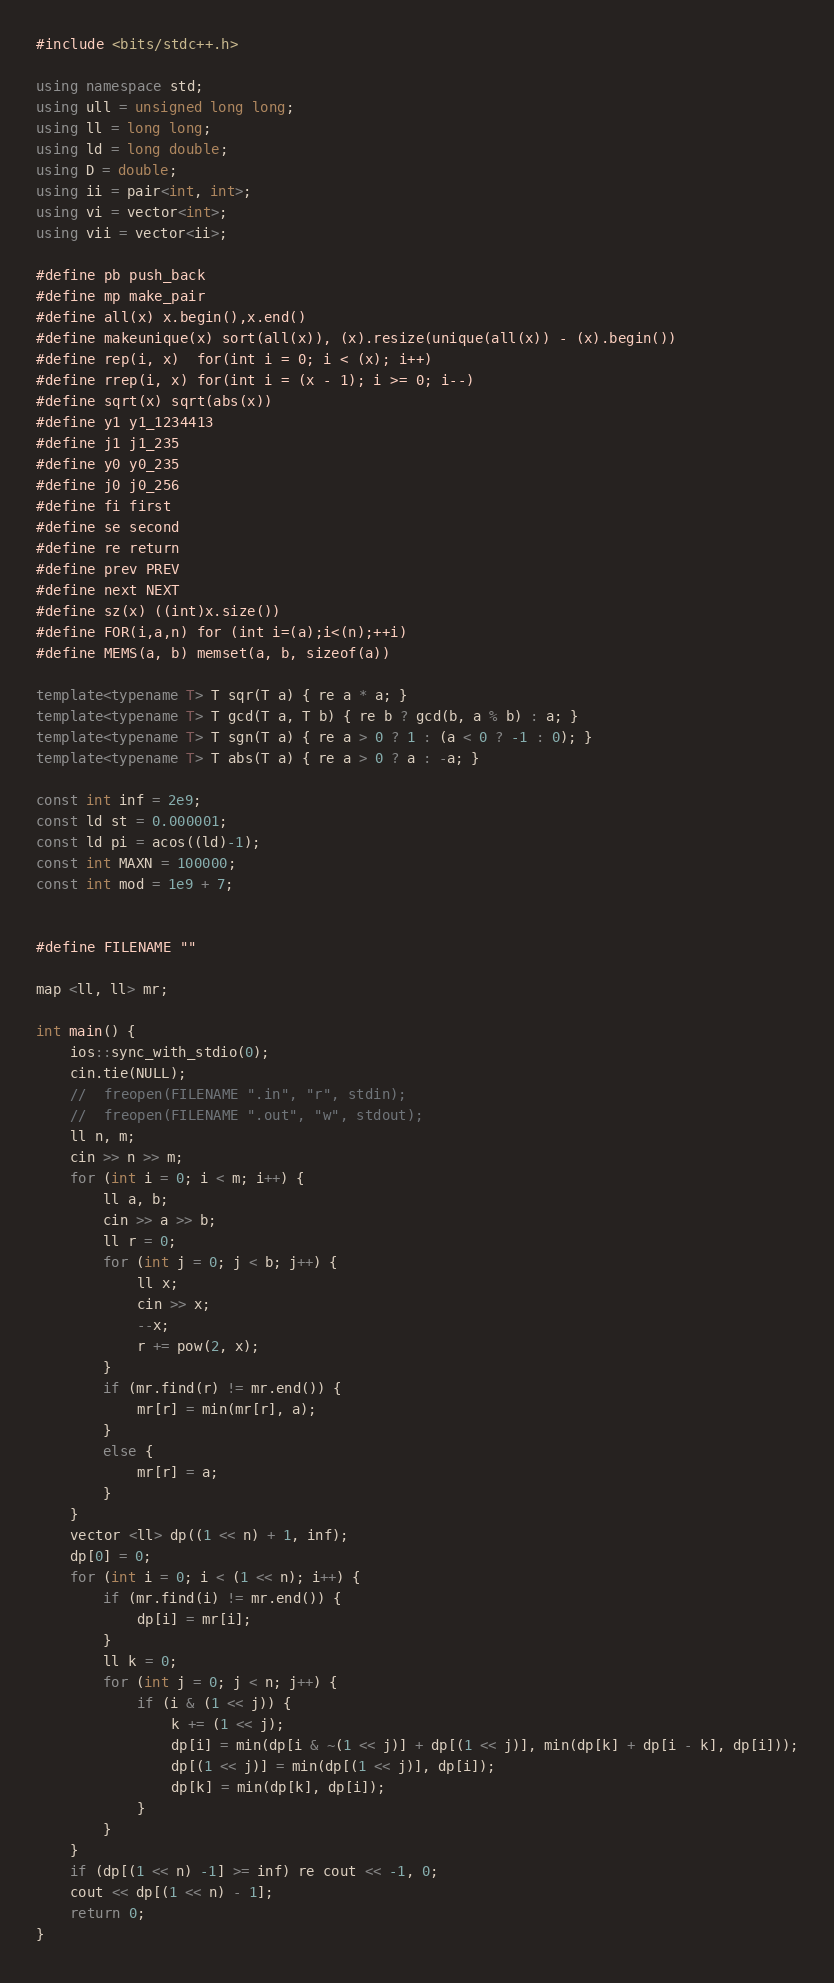<code> <loc_0><loc_0><loc_500><loc_500><_C++_>#include <bits/stdc++.h>
 
using namespace std;
using ull = unsigned long long;
using ll = long long;
using ld = long double;
using D = double;
using ii = pair<int, int>;
using vi = vector<int>;
using vii = vector<ii>;
 
#define pb push_back
#define mp make_pair
#define all(x) x.begin(),x.end()
#define makeunique(x) sort(all(x)), (x).resize(unique(all(x)) - (x).begin())
#define rep(i, x)  for(int i = 0; i < (x); i++)
#define rrep(i, x) for(int i = (x - 1); i >= 0; i--)
#define sqrt(x) sqrt(abs(x))
#define y1 y1_1234413
#define j1 j1_235
#define y0 y0_235
#define j0 j0_256
#define fi first
#define se second
#define re return
#define prev PREV
#define next NEXT
#define sz(x) ((int)x.size())
#define FOR(i,a,n) for (int i=(a);i<(n);++i)
#define MEMS(a, b) memset(a, b, sizeof(a))
 
template<typename T> T sqr(T a) { re a * a; }
template<typename T> T gcd(T a, T b) { re b ? gcd(b, a % b) : a; }
template<typename T> T sgn(T a) { re a > 0 ? 1 : (a < 0 ? -1 : 0); }
template<typename T> T abs(T a) { re a > 0 ? a : -a; }
 
const int inf = 2e9;
const ld st = 0.000001;
const ld pi = acos((ld)-1);
const int MAXN = 100000;
const int mod = 1e9 + 7;
 
 
#define FILENAME ""
                    
map <ll, ll> mr;
 
int main() {
    ios::sync_with_stdio(0);
    cin.tie(NULL);
    //  freopen(FILENAME ".in", "r", stdin);
    //  freopen(FILENAME ".out", "w", stdout);
   	ll n, m;
   	cin >> n >> m;
   	for (int i = 0; i < m; i++) {
   	 	ll a, b;
   	 	cin >> a >> b;
   	 	ll r = 0;
   	 	for (int j = 0; j < b; j++) {
   	 		ll x;
   	 		cin >> x;
   	 		--x;
   	 		r += pow(2, x);		
   	   	}	
   	   	if (mr.find(r) != mr.end()) {
   	   		mr[r] = min(mr[r], a);
   	   	}
   	   	else {
   	   	 	mr[r] = a;
   	   	}
   	}
   	vector <ll> dp((1 << n) + 1, inf);
   	dp[0] = 0;
   	for (int i = 0; i < (1 << n); i++) {
   		if (mr.find(i) != mr.end()) {
   			dp[i] = mr[i];
   		}
   		ll k = 0;
   	 	for (int j = 0; j < n; j++) {
   	 	 	if (i & (1 << j)) {
   	 	 	    k += (1 << j);
   	 	 	 	dp[i] = min(dp[i & ~(1 << j)] + dp[(1 << j)], min(dp[k] + dp[i - k], dp[i]));
   	 	 	 	dp[(1 << j)] = min(dp[(1 << j)], dp[i]);
   	 	 	 	dp[k] = min(dp[k], dp[i]);
   	 	 	}
   	 	}
    }
    if (dp[(1 << n) -1] >= inf) re cout << -1, 0;
    cout << dp[(1 << n) - 1];
    return 0;
}</code> 